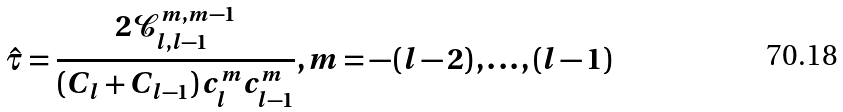<formula> <loc_0><loc_0><loc_500><loc_500>\hat { \tau } = \frac { 2 \mathcal { C } _ { l , l - 1 } ^ { m , m - 1 } } { \left ( C _ { l } + C _ { l - 1 } \right ) c _ { l } ^ { m } c _ { l - 1 } ^ { m } } , m = - \left ( l - 2 \right ) , \dots , \left ( l - 1 \right )</formula> 